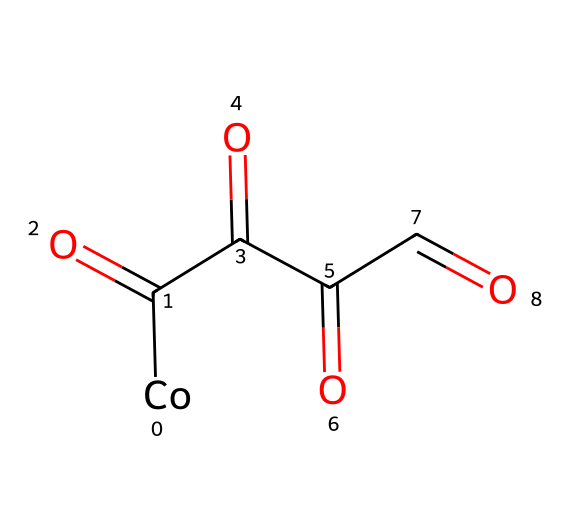What is the central metal atom in this compound? The SMILES representation shows [Co], indicating cobalt is the central metal atom.
Answer: cobalt How many carbonyl groups are present in this structure? The structure contains four C(=O) groups, as indicated by C(=O) being repeated four times in the SMILES.
Answer: four What is the coordination number of cobalt in this complex? Cobalt is bonded to four carbonyl groups, giving it a coordination number of 4.
Answer: 4 What type of reaction is this complex commonly used for? Cobalt carbonyl is employed in hydroformylation processes, which involve the addition of carbon monoxide and hydrogen.
Answer: hydroformylation What type of organometallic compound does cobalt carbonyl belong to? Cobalt carbonyl is classified as a metal carbonyl compound, which specifically consists of transition metals bonded to carbon monoxide.
Answer: metal carbonyl Is cobalt a transition metal? Yes, cobalt is located in the d-block of the periodic table, confirming it is a transition metal.
Answer: yes What is the oxidation state of cobalt in this carbonyl complex? In cobalt carbonyl complexes, cobalt typically exhibits an oxidation state of zero, as it does not lose electrons when forming bonds with carbon monoxide.
Answer: zero 